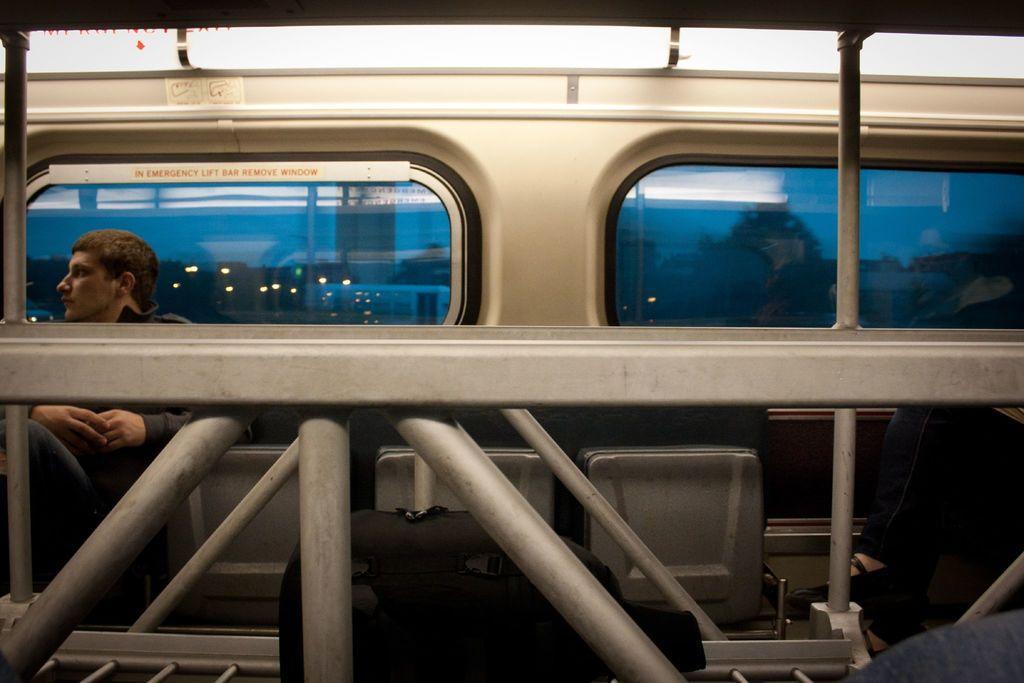Could you give a brief overview of what you see in this image? In this image we can see iron grills, windows, persons sitting on the chairs and sign boards. 